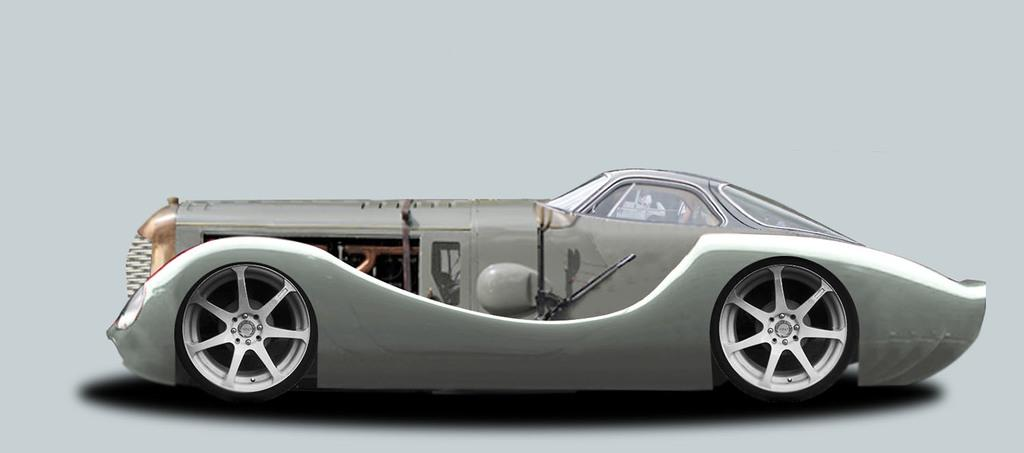What is the main subject of the picture? The main subject of the picture is a car. How is the car positioned in the image? The car is viewed from the side. What are the car's windows made of? The car has window glasses. How many wheels does the car have? The car has wheels. What color is the car in the image? The car is gray in color. Can you see any cake or seeds in the image? No, there is no cake or seeds present in the image; it features a car. Is there a collar visible on the car in the image? No, there is no collar present on the car in the image. 